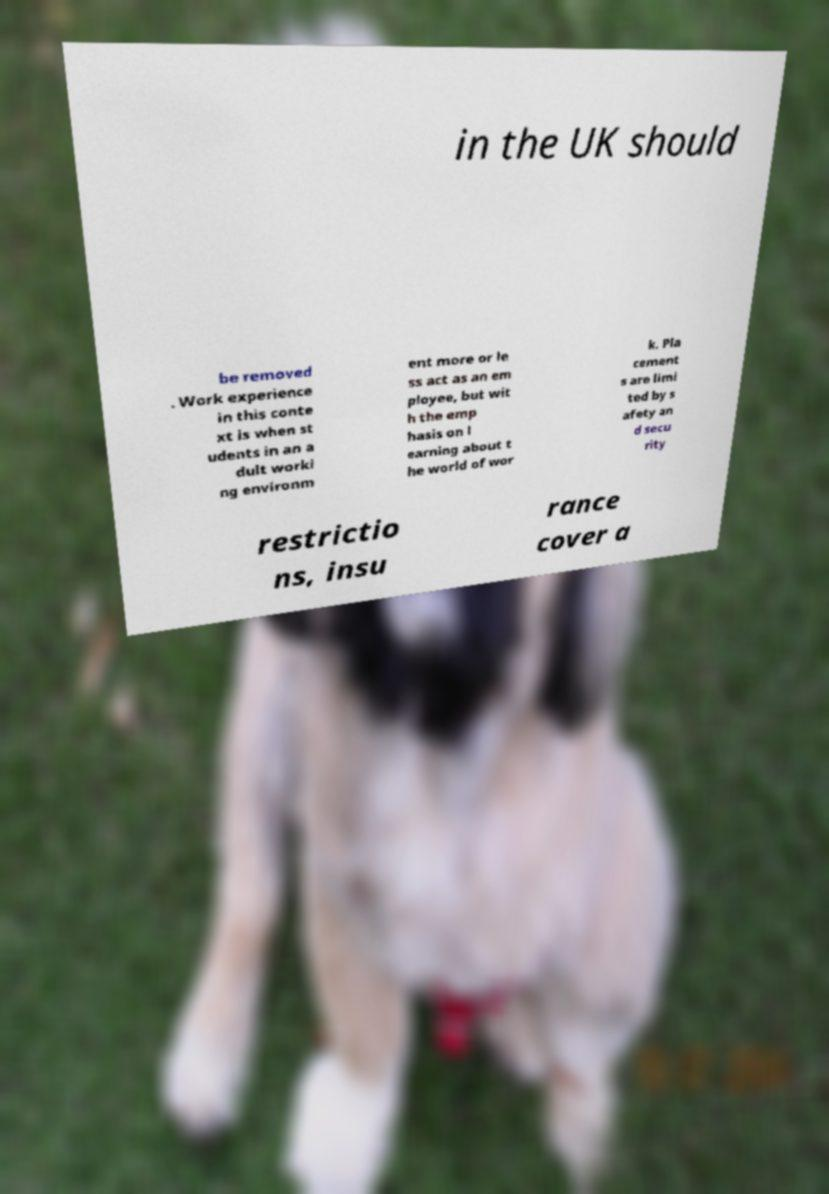There's text embedded in this image that I need extracted. Can you transcribe it verbatim? in the UK should be removed . Work experience in this conte xt is when st udents in an a dult worki ng environm ent more or le ss act as an em ployee, but wit h the emp hasis on l earning about t he world of wor k. Pla cement s are limi ted by s afety an d secu rity restrictio ns, insu rance cover a 